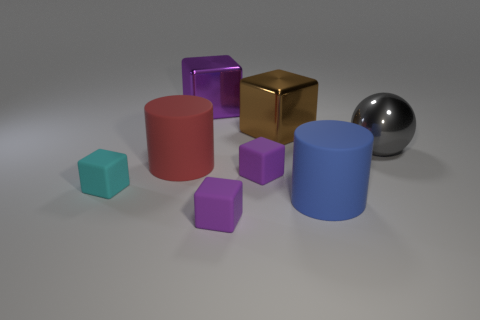Subtract all blue spheres. How many purple cubes are left? 3 Subtract all brown cubes. How many cubes are left? 4 Subtract 1 blocks. How many blocks are left? 4 Subtract all large brown cubes. How many cubes are left? 4 Subtract all yellow cubes. Subtract all brown cylinders. How many cubes are left? 5 Add 2 large rubber things. How many objects exist? 10 Subtract all balls. How many objects are left? 7 Add 1 cyan rubber objects. How many cyan rubber objects exist? 2 Subtract 0 brown cylinders. How many objects are left? 8 Subtract all spheres. Subtract all tiny purple things. How many objects are left? 5 